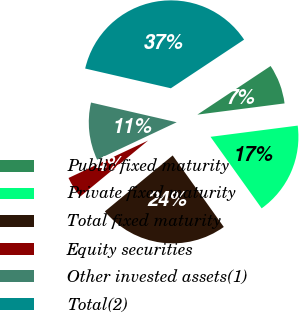Convert chart. <chart><loc_0><loc_0><loc_500><loc_500><pie_chart><fcel>Public fixed maturity<fcel>Private fixed maturity<fcel>Total fixed maturity<fcel>Equity securities<fcel>Other invested assets(1)<fcel>Total(2)<nl><fcel>7.29%<fcel>17.16%<fcel>23.9%<fcel>3.98%<fcel>10.6%<fcel>37.07%<nl></chart> 